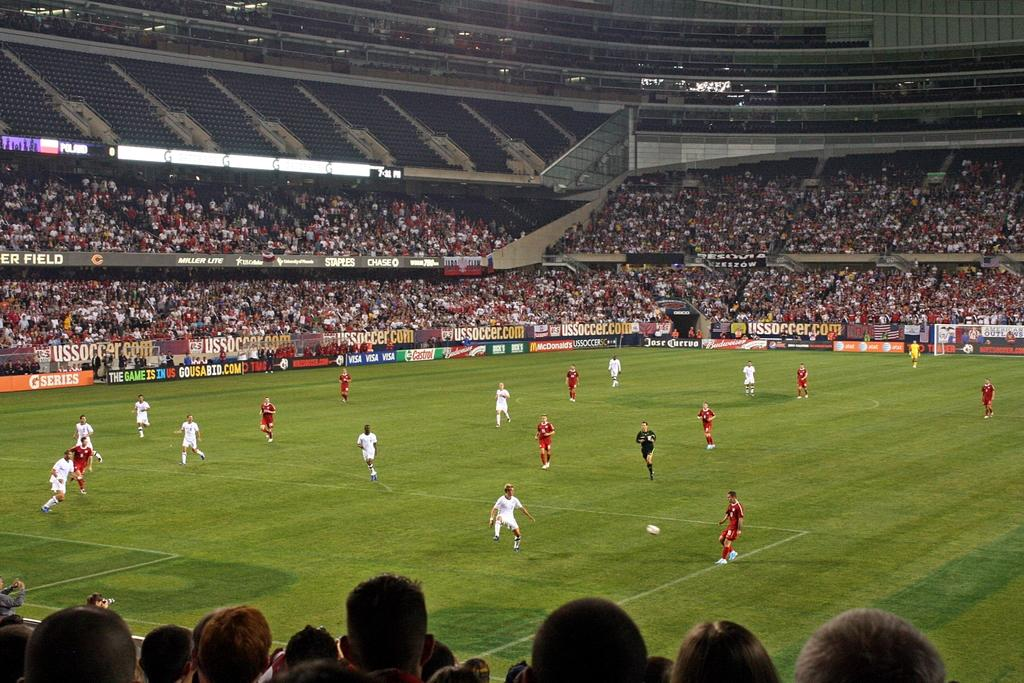Provide a one-sentence caption for the provided image. A packed soccer stadium has banner ads for items such as Gatorade and stores like Staples. 